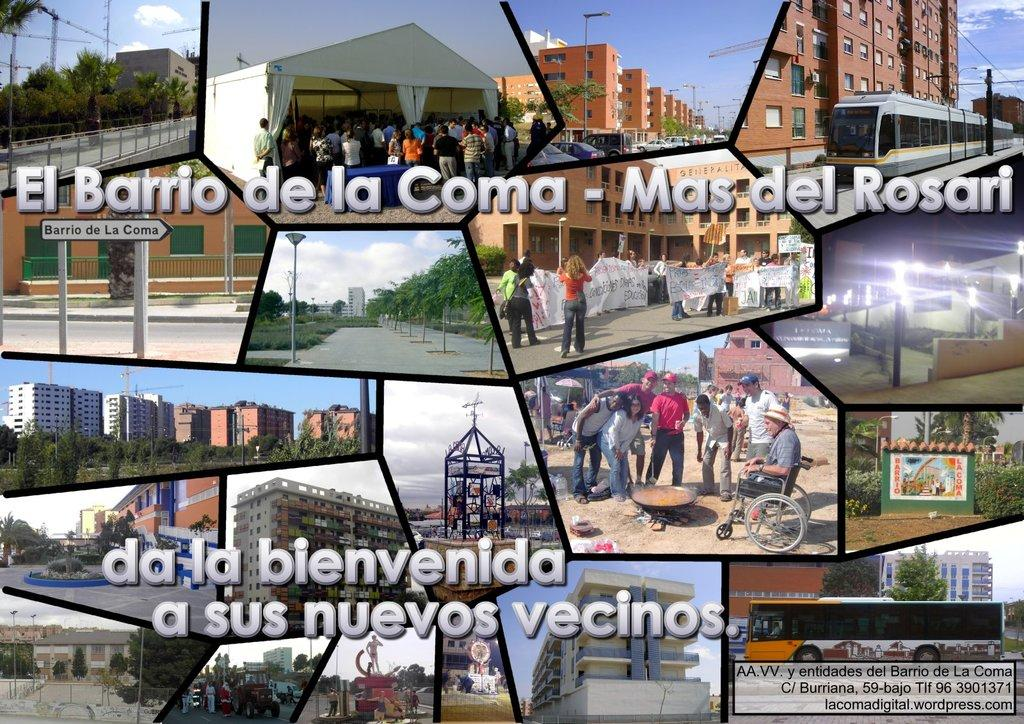What type of image is being described? The image is a collage of different places. Can you describe the composition of the collage? Unfortunately, the provided facts do not give any specific details about the composition of the collage. How many jellyfish can be seen in the image? There is no mention of jellyfish in the provided facts, so it cannot be determined if any are present in the image. 